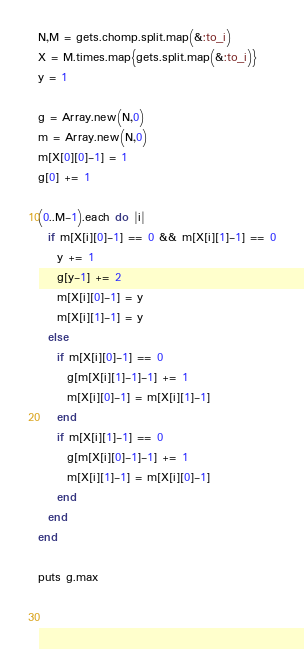Convert code to text. <code><loc_0><loc_0><loc_500><loc_500><_Ruby_>N,M = gets.chomp.split.map(&:to_i)
X = M.times.map{gets.split.map(&:to_i)}
y = 1

g = Array.new(N,0)
m = Array.new(N,0)
m[X[0][0]-1] = 1
g[0] += 1

(0..M-1).each do |i|
  if m[X[i][0]-1] == 0 && m[X[i][1]-1] == 0
    y += 1
    g[y-1] += 2
    m[X[i][0]-1] = y
    m[X[i][1]-1] = y
  else
    if m[X[i][0]-1] == 0
      g[m[X[i][1]-1]-1] += 1
      m[X[i][0]-1] = m[X[i][1]-1]
    end
    if m[X[i][1]-1] == 0
      g[m[X[i][0]-1]-1] += 1
      m[X[i][1]-1] = m[X[i][0]-1]
    end
  end
end

puts g.max
    
  </code> 